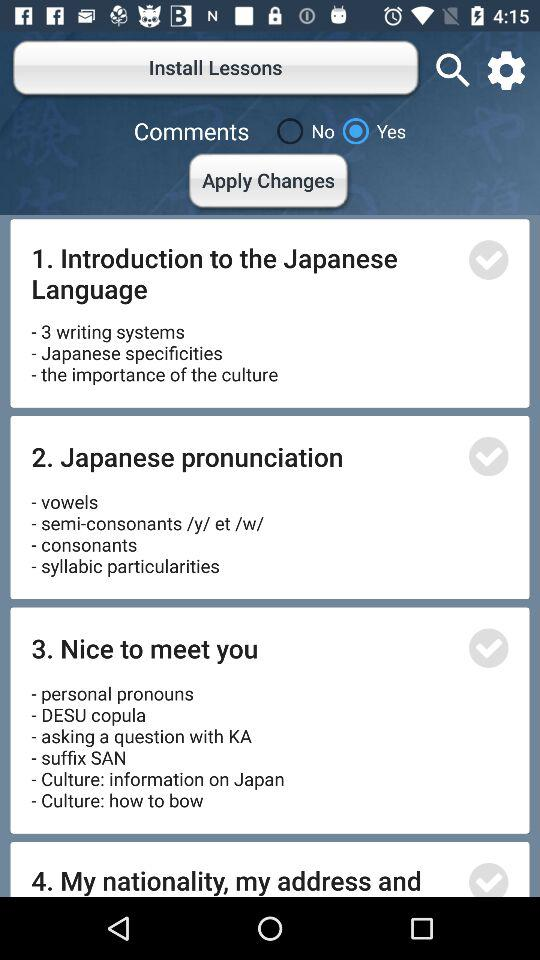What's the status of "Comments"? The status is "yes". 